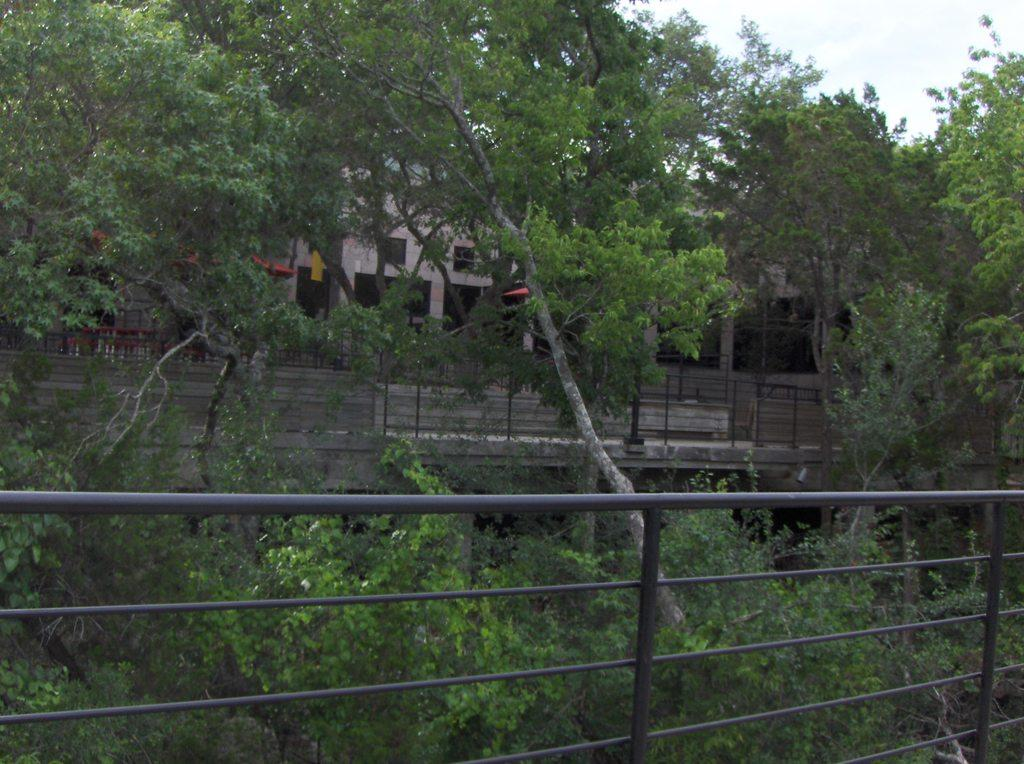What type of material is used for the railing in the image? The railing in the image is made of steel. What other natural elements can be seen in the image? There are trees in the image. What type of structures are present in the image? There are houses in the image. What separates the houses from the surrounding area? There is a fence in the image. What can be seen in the distance in the image? The sky is visible in the background of the image. Where is the patch of quicksand located in the image? There is no patch of quicksand present in the image. What type of roof is visible on the houses in the image? The provided facts do not mention the type of roof on the houses, so it cannot be determined from the image. 